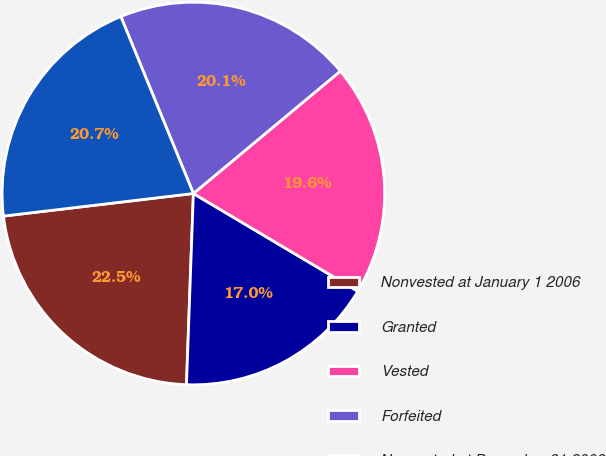<chart> <loc_0><loc_0><loc_500><loc_500><pie_chart><fcel>Nonvested at January 1 2006<fcel>Granted<fcel>Vested<fcel>Forfeited<fcel>Nonvested at December 31 2006<nl><fcel>22.54%<fcel>17.04%<fcel>19.59%<fcel>20.14%<fcel>20.69%<nl></chart> 